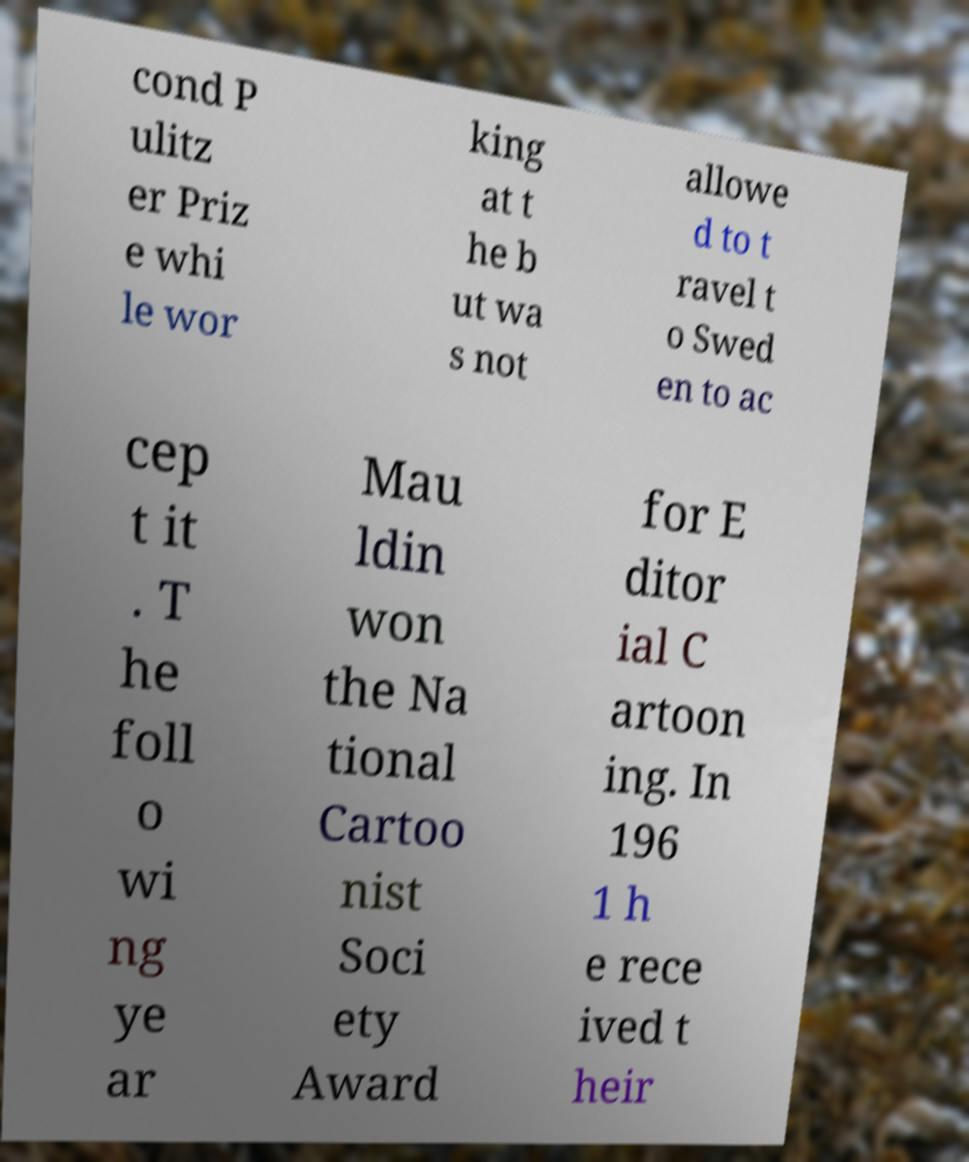For documentation purposes, I need the text within this image transcribed. Could you provide that? cond P ulitz er Priz e whi le wor king at t he b ut wa s not allowe d to t ravel t o Swed en to ac cep t it . T he foll o wi ng ye ar Mau ldin won the Na tional Cartoo nist Soci ety Award for E ditor ial C artoon ing. In 196 1 h e rece ived t heir 